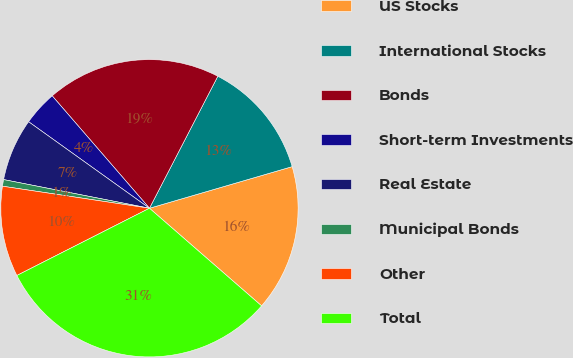Convert chart to OTSL. <chart><loc_0><loc_0><loc_500><loc_500><pie_chart><fcel>US Stocks<fcel>International Stocks<fcel>Bonds<fcel>Short-term Investments<fcel>Real Estate<fcel>Municipal Bonds<fcel>Other<fcel>Total<nl><fcel>15.92%<fcel>12.88%<fcel>18.96%<fcel>3.76%<fcel>6.8%<fcel>0.72%<fcel>9.84%<fcel>31.13%<nl></chart> 